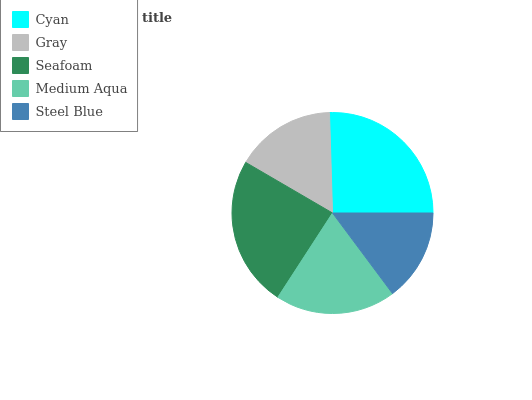Is Steel Blue the minimum?
Answer yes or no. Yes. Is Cyan the maximum?
Answer yes or no. Yes. Is Gray the minimum?
Answer yes or no. No. Is Gray the maximum?
Answer yes or no. No. Is Cyan greater than Gray?
Answer yes or no. Yes. Is Gray less than Cyan?
Answer yes or no. Yes. Is Gray greater than Cyan?
Answer yes or no. No. Is Cyan less than Gray?
Answer yes or no. No. Is Medium Aqua the high median?
Answer yes or no. Yes. Is Medium Aqua the low median?
Answer yes or no. Yes. Is Gray the high median?
Answer yes or no. No. Is Steel Blue the low median?
Answer yes or no. No. 